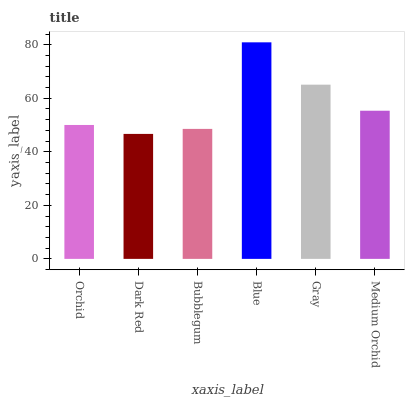Is Dark Red the minimum?
Answer yes or no. Yes. Is Blue the maximum?
Answer yes or no. Yes. Is Bubblegum the minimum?
Answer yes or no. No. Is Bubblegum the maximum?
Answer yes or no. No. Is Bubblegum greater than Dark Red?
Answer yes or no. Yes. Is Dark Red less than Bubblegum?
Answer yes or no. Yes. Is Dark Red greater than Bubblegum?
Answer yes or no. No. Is Bubblegum less than Dark Red?
Answer yes or no. No. Is Medium Orchid the high median?
Answer yes or no. Yes. Is Orchid the low median?
Answer yes or no. Yes. Is Orchid the high median?
Answer yes or no. No. Is Blue the low median?
Answer yes or no. No. 